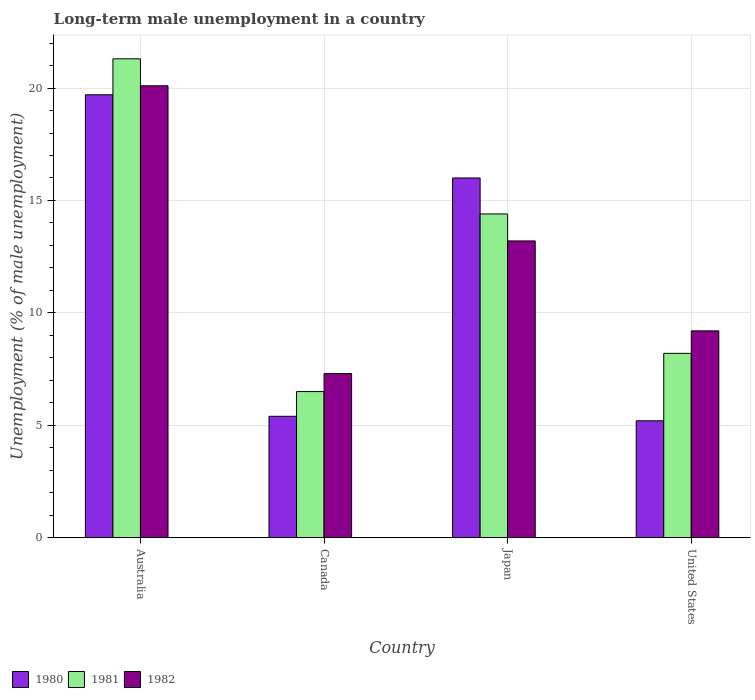How many different coloured bars are there?
Keep it short and to the point. 3. How many groups of bars are there?
Provide a succinct answer. 4. How many bars are there on the 2nd tick from the right?
Give a very brief answer. 3. In how many cases, is the number of bars for a given country not equal to the number of legend labels?
Keep it short and to the point. 0. What is the percentage of long-term unemployed male population in 1981 in United States?
Ensure brevity in your answer.  8.2. Across all countries, what is the maximum percentage of long-term unemployed male population in 1981?
Ensure brevity in your answer.  21.3. Across all countries, what is the minimum percentage of long-term unemployed male population in 1982?
Your answer should be compact. 7.3. What is the total percentage of long-term unemployed male population in 1981 in the graph?
Offer a terse response. 50.4. What is the difference between the percentage of long-term unemployed male population in 1981 in Canada and that in Japan?
Ensure brevity in your answer.  -7.9. What is the difference between the percentage of long-term unemployed male population in 1982 in Canada and the percentage of long-term unemployed male population in 1981 in United States?
Make the answer very short. -0.9. What is the average percentage of long-term unemployed male population in 1982 per country?
Keep it short and to the point. 12.45. What is the difference between the percentage of long-term unemployed male population of/in 1980 and percentage of long-term unemployed male population of/in 1982 in Canada?
Provide a succinct answer. -1.9. In how many countries, is the percentage of long-term unemployed male population in 1981 greater than 2 %?
Your answer should be compact. 4. What is the ratio of the percentage of long-term unemployed male population in 1980 in Australia to that in Canada?
Your response must be concise. 3.65. Is the difference between the percentage of long-term unemployed male population in 1980 in Australia and Japan greater than the difference between the percentage of long-term unemployed male population in 1982 in Australia and Japan?
Offer a very short reply. No. What is the difference between the highest and the second highest percentage of long-term unemployed male population in 1981?
Provide a short and direct response. -13.1. What is the difference between the highest and the lowest percentage of long-term unemployed male population in 1982?
Your answer should be compact. 12.8. In how many countries, is the percentage of long-term unemployed male population in 1981 greater than the average percentage of long-term unemployed male population in 1981 taken over all countries?
Your answer should be compact. 2. What does the 3rd bar from the left in Canada represents?
Your answer should be very brief. 1982. How many bars are there?
Give a very brief answer. 12. How many countries are there in the graph?
Keep it short and to the point. 4. What is the difference between two consecutive major ticks on the Y-axis?
Your response must be concise. 5. Where does the legend appear in the graph?
Your answer should be very brief. Bottom left. How many legend labels are there?
Provide a short and direct response. 3. What is the title of the graph?
Ensure brevity in your answer.  Long-term male unemployment in a country. Does "1991" appear as one of the legend labels in the graph?
Your answer should be very brief. No. What is the label or title of the X-axis?
Offer a very short reply. Country. What is the label or title of the Y-axis?
Provide a short and direct response. Unemployment (% of male unemployment). What is the Unemployment (% of male unemployment) in 1980 in Australia?
Provide a succinct answer. 19.7. What is the Unemployment (% of male unemployment) of 1981 in Australia?
Keep it short and to the point. 21.3. What is the Unemployment (% of male unemployment) of 1982 in Australia?
Make the answer very short. 20.1. What is the Unemployment (% of male unemployment) in 1980 in Canada?
Your answer should be compact. 5.4. What is the Unemployment (% of male unemployment) of 1981 in Canada?
Your answer should be compact. 6.5. What is the Unemployment (% of male unemployment) in 1982 in Canada?
Offer a terse response. 7.3. What is the Unemployment (% of male unemployment) in 1980 in Japan?
Your answer should be compact. 16. What is the Unemployment (% of male unemployment) of 1981 in Japan?
Provide a succinct answer. 14.4. What is the Unemployment (% of male unemployment) in 1982 in Japan?
Ensure brevity in your answer.  13.2. What is the Unemployment (% of male unemployment) of 1980 in United States?
Your answer should be very brief. 5.2. What is the Unemployment (% of male unemployment) of 1981 in United States?
Keep it short and to the point. 8.2. What is the Unemployment (% of male unemployment) of 1982 in United States?
Provide a succinct answer. 9.2. Across all countries, what is the maximum Unemployment (% of male unemployment) of 1980?
Give a very brief answer. 19.7. Across all countries, what is the maximum Unemployment (% of male unemployment) of 1981?
Your answer should be compact. 21.3. Across all countries, what is the maximum Unemployment (% of male unemployment) in 1982?
Your answer should be very brief. 20.1. Across all countries, what is the minimum Unemployment (% of male unemployment) of 1980?
Provide a short and direct response. 5.2. Across all countries, what is the minimum Unemployment (% of male unemployment) in 1981?
Provide a short and direct response. 6.5. Across all countries, what is the minimum Unemployment (% of male unemployment) of 1982?
Keep it short and to the point. 7.3. What is the total Unemployment (% of male unemployment) of 1980 in the graph?
Give a very brief answer. 46.3. What is the total Unemployment (% of male unemployment) in 1981 in the graph?
Offer a terse response. 50.4. What is the total Unemployment (% of male unemployment) in 1982 in the graph?
Provide a short and direct response. 49.8. What is the difference between the Unemployment (% of male unemployment) in 1981 in Australia and that in Japan?
Ensure brevity in your answer.  6.9. What is the difference between the Unemployment (% of male unemployment) of 1981 in Australia and that in United States?
Provide a short and direct response. 13.1. What is the difference between the Unemployment (% of male unemployment) of 1980 in Canada and that in Japan?
Provide a short and direct response. -10.6. What is the difference between the Unemployment (% of male unemployment) in 1981 in Canada and that in Japan?
Provide a short and direct response. -7.9. What is the difference between the Unemployment (% of male unemployment) of 1981 in Canada and that in United States?
Give a very brief answer. -1.7. What is the difference between the Unemployment (% of male unemployment) of 1981 in Japan and that in United States?
Provide a succinct answer. 6.2. What is the difference between the Unemployment (% of male unemployment) in 1980 in Australia and the Unemployment (% of male unemployment) in 1981 in Canada?
Keep it short and to the point. 13.2. What is the difference between the Unemployment (% of male unemployment) of 1980 in Australia and the Unemployment (% of male unemployment) of 1982 in Canada?
Ensure brevity in your answer.  12.4. What is the difference between the Unemployment (% of male unemployment) in 1981 in Australia and the Unemployment (% of male unemployment) in 1982 in Canada?
Keep it short and to the point. 14. What is the difference between the Unemployment (% of male unemployment) of 1980 in Australia and the Unemployment (% of male unemployment) of 1982 in Japan?
Keep it short and to the point. 6.5. What is the difference between the Unemployment (% of male unemployment) in 1980 in Australia and the Unemployment (% of male unemployment) in 1981 in United States?
Keep it short and to the point. 11.5. What is the difference between the Unemployment (% of male unemployment) in 1981 in Australia and the Unemployment (% of male unemployment) in 1982 in United States?
Give a very brief answer. 12.1. What is the difference between the Unemployment (% of male unemployment) of 1980 in Canada and the Unemployment (% of male unemployment) of 1981 in Japan?
Keep it short and to the point. -9. What is the average Unemployment (% of male unemployment) in 1980 per country?
Your response must be concise. 11.57. What is the average Unemployment (% of male unemployment) of 1982 per country?
Your answer should be very brief. 12.45. What is the difference between the Unemployment (% of male unemployment) in 1980 and Unemployment (% of male unemployment) in 1982 in Australia?
Offer a terse response. -0.4. What is the difference between the Unemployment (% of male unemployment) of 1980 and Unemployment (% of male unemployment) of 1982 in Japan?
Offer a very short reply. 2.8. What is the difference between the Unemployment (% of male unemployment) in 1981 and Unemployment (% of male unemployment) in 1982 in Japan?
Ensure brevity in your answer.  1.2. What is the difference between the Unemployment (% of male unemployment) of 1981 and Unemployment (% of male unemployment) of 1982 in United States?
Offer a terse response. -1. What is the ratio of the Unemployment (% of male unemployment) in 1980 in Australia to that in Canada?
Offer a terse response. 3.65. What is the ratio of the Unemployment (% of male unemployment) of 1981 in Australia to that in Canada?
Keep it short and to the point. 3.28. What is the ratio of the Unemployment (% of male unemployment) of 1982 in Australia to that in Canada?
Provide a succinct answer. 2.75. What is the ratio of the Unemployment (% of male unemployment) in 1980 in Australia to that in Japan?
Offer a terse response. 1.23. What is the ratio of the Unemployment (% of male unemployment) in 1981 in Australia to that in Japan?
Make the answer very short. 1.48. What is the ratio of the Unemployment (% of male unemployment) in 1982 in Australia to that in Japan?
Your answer should be very brief. 1.52. What is the ratio of the Unemployment (% of male unemployment) of 1980 in Australia to that in United States?
Offer a terse response. 3.79. What is the ratio of the Unemployment (% of male unemployment) of 1981 in Australia to that in United States?
Give a very brief answer. 2.6. What is the ratio of the Unemployment (% of male unemployment) of 1982 in Australia to that in United States?
Offer a terse response. 2.18. What is the ratio of the Unemployment (% of male unemployment) in 1980 in Canada to that in Japan?
Make the answer very short. 0.34. What is the ratio of the Unemployment (% of male unemployment) in 1981 in Canada to that in Japan?
Keep it short and to the point. 0.45. What is the ratio of the Unemployment (% of male unemployment) of 1982 in Canada to that in Japan?
Make the answer very short. 0.55. What is the ratio of the Unemployment (% of male unemployment) of 1981 in Canada to that in United States?
Your answer should be compact. 0.79. What is the ratio of the Unemployment (% of male unemployment) of 1982 in Canada to that in United States?
Your response must be concise. 0.79. What is the ratio of the Unemployment (% of male unemployment) of 1980 in Japan to that in United States?
Offer a terse response. 3.08. What is the ratio of the Unemployment (% of male unemployment) in 1981 in Japan to that in United States?
Your response must be concise. 1.76. What is the ratio of the Unemployment (% of male unemployment) of 1982 in Japan to that in United States?
Your answer should be very brief. 1.43. What is the difference between the highest and the second highest Unemployment (% of male unemployment) in 1980?
Provide a succinct answer. 3.7. What is the difference between the highest and the second highest Unemployment (% of male unemployment) of 1982?
Provide a short and direct response. 6.9. What is the difference between the highest and the lowest Unemployment (% of male unemployment) in 1982?
Your answer should be compact. 12.8. 